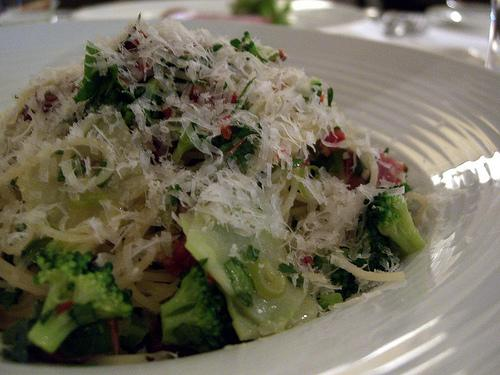For a product advertisement task, describe the features and appearance of the plate that make it an attractive serving option. The round white plate is a sleek and elegant choice for serving your dishes, with its minimalist color and unique ripple texture that adds an extra touch of sophistication to your presentation. Imagine you are describing this dish to a friend over the phone. What would you tell them about the food and the plate it is served on? I would say it's a delicious-looking dish with green broccoli, cheesy toppings, and some fresh veggies, all served on a round white plate that has an interesting ripple texture. Mention a few items that can be seen on the plate and their characteristics. Some items on the plate include green broccoli, food with cheese on top, and white shreddings. For a multi-choice VQA task, what type of garnish is present on the broccoli? White topping Based on the image, choose a suitable advertisement slogan for the food presented on the plate. "Deliciously Nutritious: Dive into a plate of wholesome goodness with our broccoli, cheese, and fresh vegetable medley!" What is the color and shape of the plate, as seen from the image? The plate is white in color and has a round shape. For a visual entailment task, describe the relationship between the plate and the food items on it. The plate supports and displays the food items, presenting them in an appetizing arrangement. Identify the main object on the plate and describe its main characteristics. The main object on the plate is broccoli, which is green in color and has a distinct head and stem structure. 